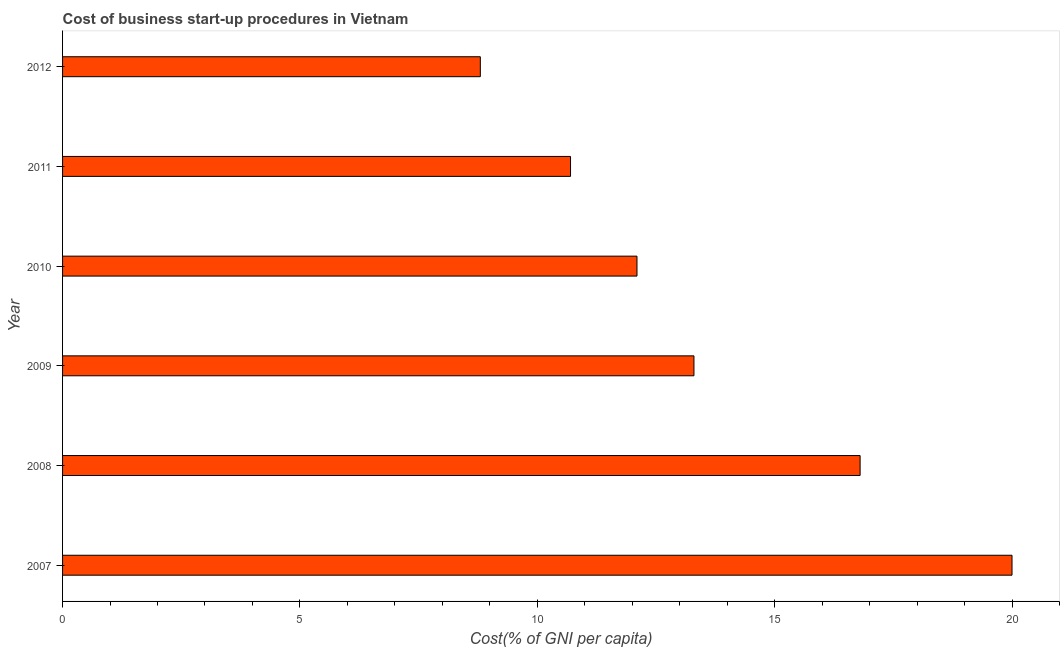Does the graph contain any zero values?
Your answer should be compact. No. Does the graph contain grids?
Offer a terse response. No. What is the title of the graph?
Ensure brevity in your answer.  Cost of business start-up procedures in Vietnam. What is the label or title of the X-axis?
Ensure brevity in your answer.  Cost(% of GNI per capita). Across all years, what is the minimum cost of business startup procedures?
Offer a very short reply. 8.8. In which year was the cost of business startup procedures maximum?
Ensure brevity in your answer.  2007. What is the sum of the cost of business startup procedures?
Offer a very short reply. 81.7. What is the average cost of business startup procedures per year?
Provide a succinct answer. 13.62. Do a majority of the years between 2011 and 2007 (inclusive) have cost of business startup procedures greater than 6 %?
Offer a terse response. Yes. What is the ratio of the cost of business startup procedures in 2008 to that in 2010?
Your answer should be compact. 1.39. Is the sum of the cost of business startup procedures in 2007 and 2009 greater than the maximum cost of business startup procedures across all years?
Make the answer very short. Yes. What is the difference between the highest and the lowest cost of business startup procedures?
Your response must be concise. 11.2. Are the values on the major ticks of X-axis written in scientific E-notation?
Provide a short and direct response. No. What is the Cost(% of GNI per capita) of 2007?
Provide a succinct answer. 20. What is the Cost(% of GNI per capita) of 2008?
Provide a short and direct response. 16.8. What is the Cost(% of GNI per capita) of 2009?
Ensure brevity in your answer.  13.3. What is the Cost(% of GNI per capita) in 2011?
Offer a terse response. 10.7. What is the difference between the Cost(% of GNI per capita) in 2007 and 2008?
Ensure brevity in your answer.  3.2. What is the difference between the Cost(% of GNI per capita) in 2007 and 2009?
Your response must be concise. 6.7. What is the difference between the Cost(% of GNI per capita) in 2007 and 2010?
Provide a succinct answer. 7.9. What is the difference between the Cost(% of GNI per capita) in 2008 and 2009?
Ensure brevity in your answer.  3.5. What is the difference between the Cost(% of GNI per capita) in 2008 and 2012?
Keep it short and to the point. 8. What is the difference between the Cost(% of GNI per capita) in 2010 and 2011?
Your answer should be compact. 1.4. What is the difference between the Cost(% of GNI per capita) in 2011 and 2012?
Offer a terse response. 1.9. What is the ratio of the Cost(% of GNI per capita) in 2007 to that in 2008?
Keep it short and to the point. 1.19. What is the ratio of the Cost(% of GNI per capita) in 2007 to that in 2009?
Your answer should be very brief. 1.5. What is the ratio of the Cost(% of GNI per capita) in 2007 to that in 2010?
Your response must be concise. 1.65. What is the ratio of the Cost(% of GNI per capita) in 2007 to that in 2011?
Ensure brevity in your answer.  1.87. What is the ratio of the Cost(% of GNI per capita) in 2007 to that in 2012?
Provide a succinct answer. 2.27. What is the ratio of the Cost(% of GNI per capita) in 2008 to that in 2009?
Make the answer very short. 1.26. What is the ratio of the Cost(% of GNI per capita) in 2008 to that in 2010?
Offer a terse response. 1.39. What is the ratio of the Cost(% of GNI per capita) in 2008 to that in 2011?
Provide a short and direct response. 1.57. What is the ratio of the Cost(% of GNI per capita) in 2008 to that in 2012?
Your response must be concise. 1.91. What is the ratio of the Cost(% of GNI per capita) in 2009 to that in 2010?
Ensure brevity in your answer.  1.1. What is the ratio of the Cost(% of GNI per capita) in 2009 to that in 2011?
Keep it short and to the point. 1.24. What is the ratio of the Cost(% of GNI per capita) in 2009 to that in 2012?
Give a very brief answer. 1.51. What is the ratio of the Cost(% of GNI per capita) in 2010 to that in 2011?
Your answer should be very brief. 1.13. What is the ratio of the Cost(% of GNI per capita) in 2010 to that in 2012?
Your answer should be compact. 1.38. What is the ratio of the Cost(% of GNI per capita) in 2011 to that in 2012?
Give a very brief answer. 1.22. 